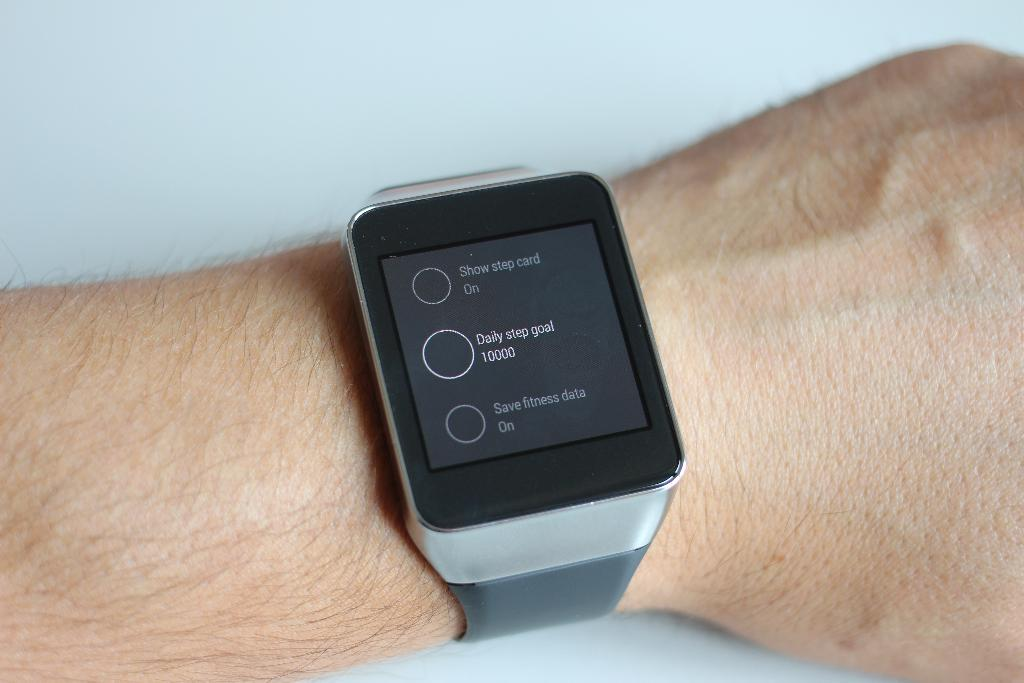Provide a one-sentence caption for the provided image. A wrist is shown with a smart watch that displays a daily step goal of 10,000 steps. 